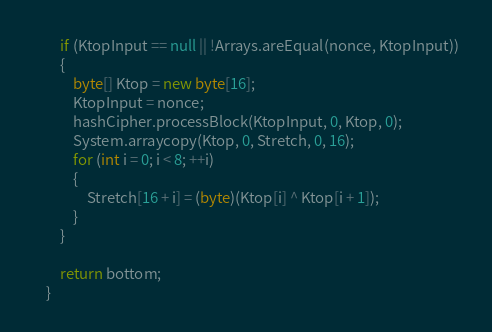<code> <loc_0><loc_0><loc_500><loc_500><_Java_>        if (KtopInput == null || !Arrays.areEqual(nonce, KtopInput))
        {
            byte[] Ktop = new byte[16];
            KtopInput = nonce;
            hashCipher.processBlock(KtopInput, 0, Ktop, 0);
            System.arraycopy(Ktop, 0, Stretch, 0, 16);
            for (int i = 0; i < 8; ++i)
            {
                Stretch[16 + i] = (byte)(Ktop[i] ^ Ktop[i + 1]);
            }
        }

        return bottom;
    }
</code> 